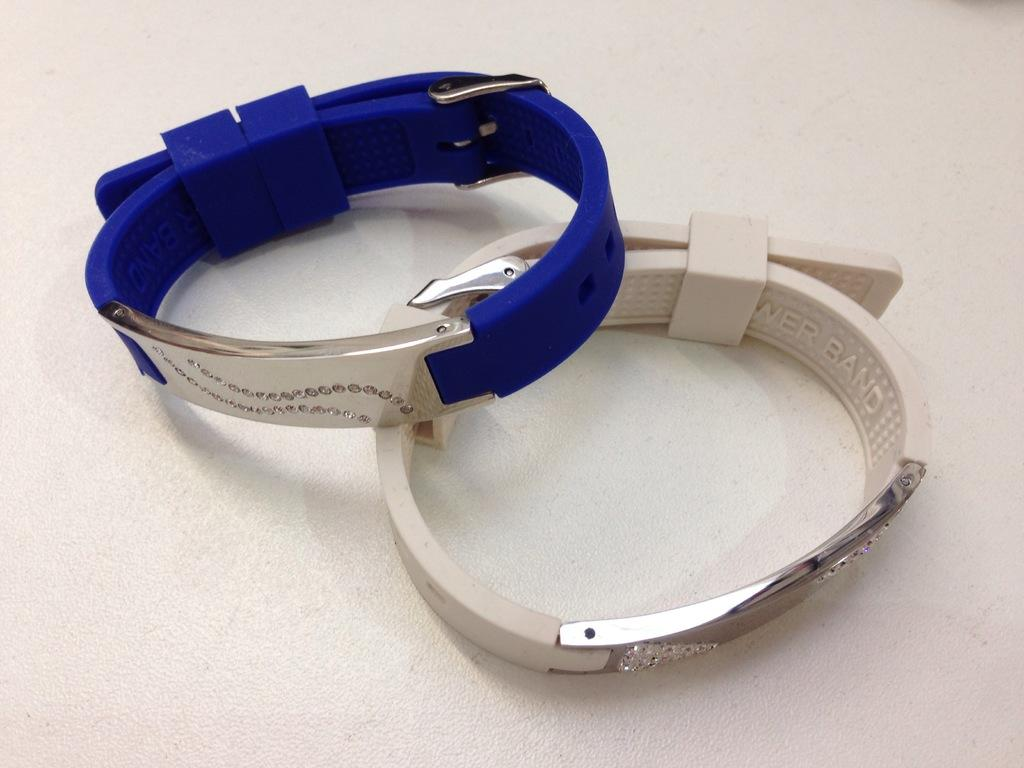How many bands are visible in the image? There are two bands in the image. What are the colors of the bands? One band is blue in color, and the other band is white in color. On what surface are the bands placed? The bands are placed on a white surface. What songs are being sung by the bands in the image? There is no information about songs being sung in the image, as it only shows the bands and their colors. 